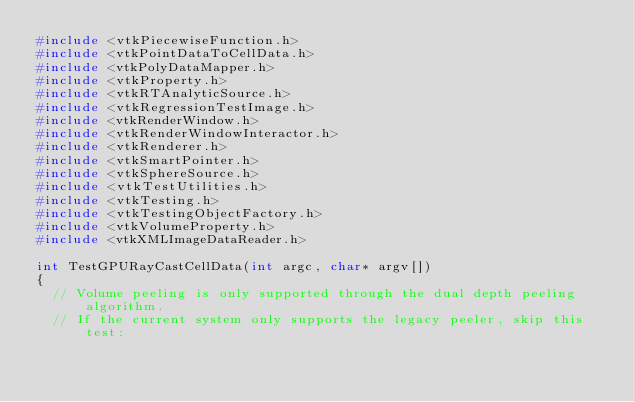Convert code to text. <code><loc_0><loc_0><loc_500><loc_500><_C++_>#include <vtkPiecewiseFunction.h>
#include <vtkPointDataToCellData.h>
#include <vtkPolyDataMapper.h>
#include <vtkProperty.h>
#include <vtkRTAnalyticSource.h>
#include <vtkRegressionTestImage.h>
#include <vtkRenderWindow.h>
#include <vtkRenderWindowInteractor.h>
#include <vtkRenderer.h>
#include <vtkSmartPointer.h>
#include <vtkSphereSource.h>
#include <vtkTestUtilities.h>
#include <vtkTesting.h>
#include <vtkTestingObjectFactory.h>
#include <vtkVolumeProperty.h>
#include <vtkXMLImageDataReader.h>

int TestGPURayCastCellData(int argc, char* argv[])
{
  // Volume peeling is only supported through the dual depth peeling algorithm.
  // If the current system only supports the legacy peeler, skip this test:</code> 